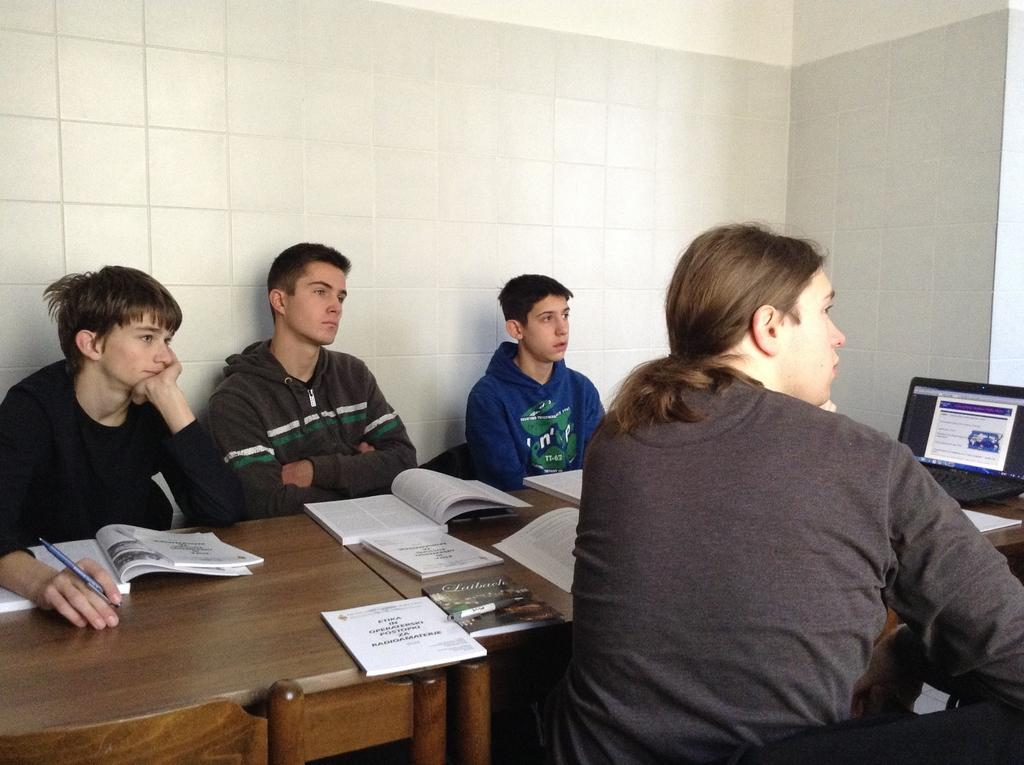What type of space is depicted in the image? There is a room in the image. What are the people in the room doing? The people are sitting in chairs in the room. What objects are the people holding? The people are holding books. Where are the books located when not being held? The books are on a table. What electronic device is also present on the table? There is a laptop on the table. How does the man on the earth increase his knowledge in the image? There is no man or earth present in the image, and the people are already increasing their knowledge by reading books. 